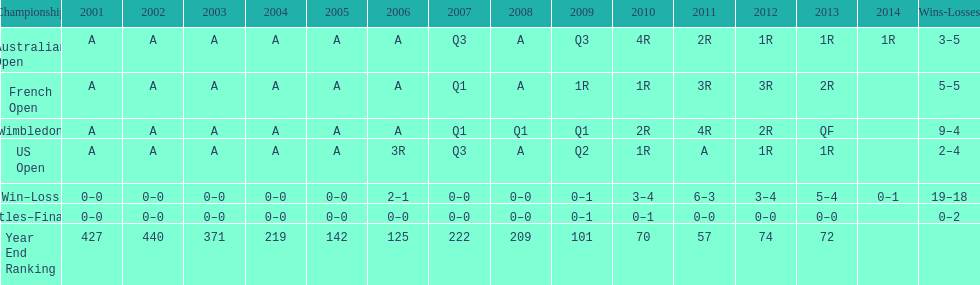Could you parse the entire table as a dict? {'header': ['Championship', '2001', '2002', '2003', '2004', '2005', '2006', '2007', '2008', '2009', '2010', '2011', '2012', '2013', '2014', 'Wins-Losses'], 'rows': [['Australian Open', 'A', 'A', 'A', 'A', 'A', 'A', 'Q3', 'A', 'Q3', '4R', '2R', '1R', '1R', '1R', '3–5'], ['French Open', 'A', 'A', 'A', 'A', 'A', 'A', 'Q1', 'A', '1R', '1R', '3R', '3R', '2R', '', '5–5'], ['Wimbledon', 'A', 'A', 'A', 'A', 'A', 'A', 'Q1', 'Q1', 'Q1', '2R', '4R', '2R', 'QF', '', '9–4'], ['US Open', 'A', 'A', 'A', 'A', 'A', '3R', 'Q3', 'A', 'Q2', '1R', 'A', '1R', '1R', '', '2–4'], ['Win–Loss', '0–0', '0–0', '0–0', '0–0', '0–0', '2–1', '0–0', '0–0', '0–1', '3–4', '6–3', '3–4', '5–4', '0–1', '19–18'], ['Titles–Finals', '0–0', '0–0', '0–0', '0–0', '0–0', '0–0', '0–0', '0–0', '0–1', '0–1', '0–0', '0–0', '0–0', '', '0–2'], ['Year End Ranking', '427', '440', '371', '219', '142', '125', '222', '209', '101', '70', '57', '74', '72', '', '']]} What is the difference in wins between wimbledon and the us open for this player? 7. 